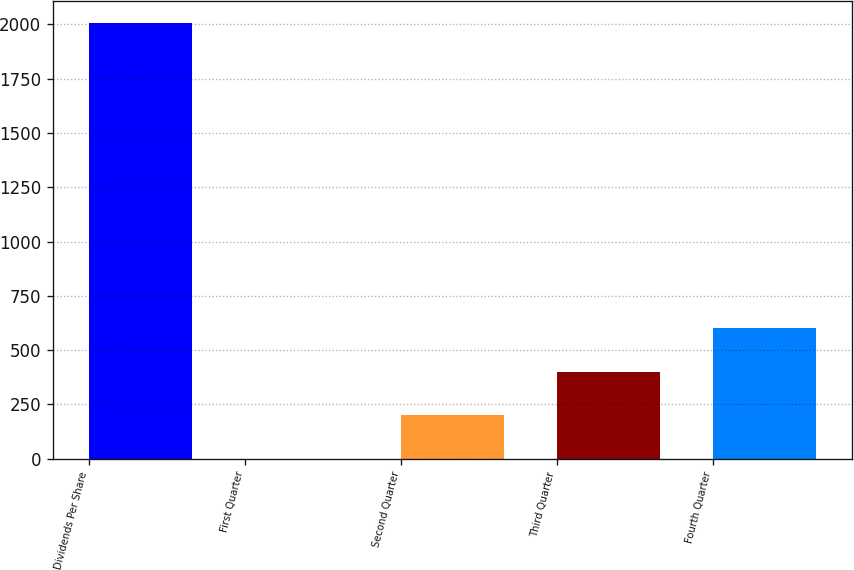Convert chart to OTSL. <chart><loc_0><loc_0><loc_500><loc_500><bar_chart><fcel>Dividends Per Share<fcel>First Quarter<fcel>Second Quarter<fcel>Third Quarter<fcel>Fourth Quarter<nl><fcel>2007<fcel>0.22<fcel>200.9<fcel>401.58<fcel>602.26<nl></chart> 